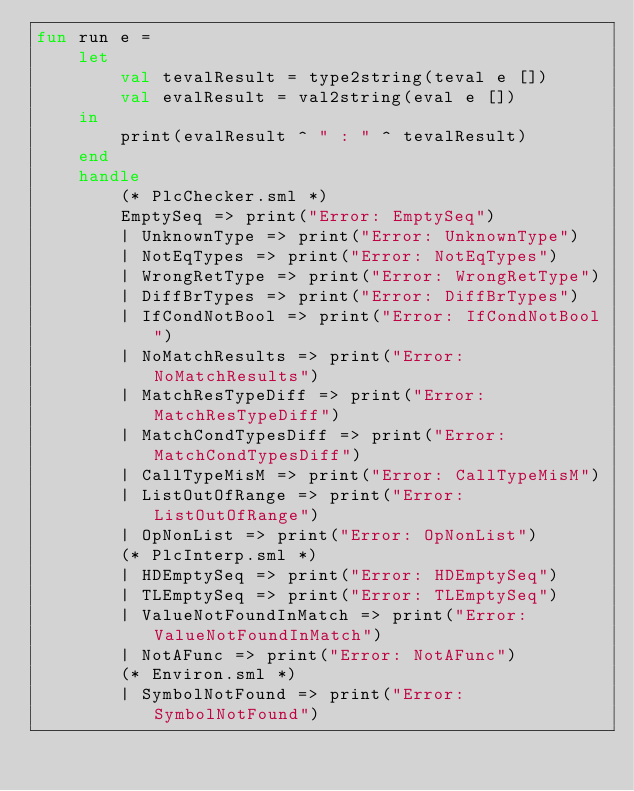Convert code to text. <code><loc_0><loc_0><loc_500><loc_500><_SML_>fun run e =
    let
        val tevalResult = type2string(teval e [])
        val evalResult = val2string(eval e [])
    in
        print(evalResult ^ " : " ^ tevalResult)
    end
    handle
        (* PlcChecker.sml *)
        EmptySeq => print("Error: EmptySeq")
        | UnknownType => print("Error: UnknownType")
        | NotEqTypes => print("Error: NotEqTypes")
        | WrongRetType => print("Error: WrongRetType")
        | DiffBrTypes => print("Error: DiffBrTypes")
        | IfCondNotBool => print("Error: IfCondNotBool")
        | NoMatchResults => print("Error: NoMatchResults")
        | MatchResTypeDiff => print("Error: MatchResTypeDiff")
        | MatchCondTypesDiff => print("Error: MatchCondTypesDiff")
        | CallTypeMisM => print("Error: CallTypeMisM")
        | ListOutOfRange => print("Error: ListOutOfRange")
        | OpNonList => print("Error: OpNonList")
        (* PlcInterp.sml *)
        | HDEmptySeq => print("Error: HDEmptySeq")
        | TLEmptySeq => print("Error: TLEmptySeq")
        | ValueNotFoundInMatch => print("Error: ValueNotFoundInMatch")
        | NotAFunc => print("Error: NotAFunc")
        (* Environ.sml *)
        | SymbolNotFound => print("Error: SymbolNotFound")</code> 